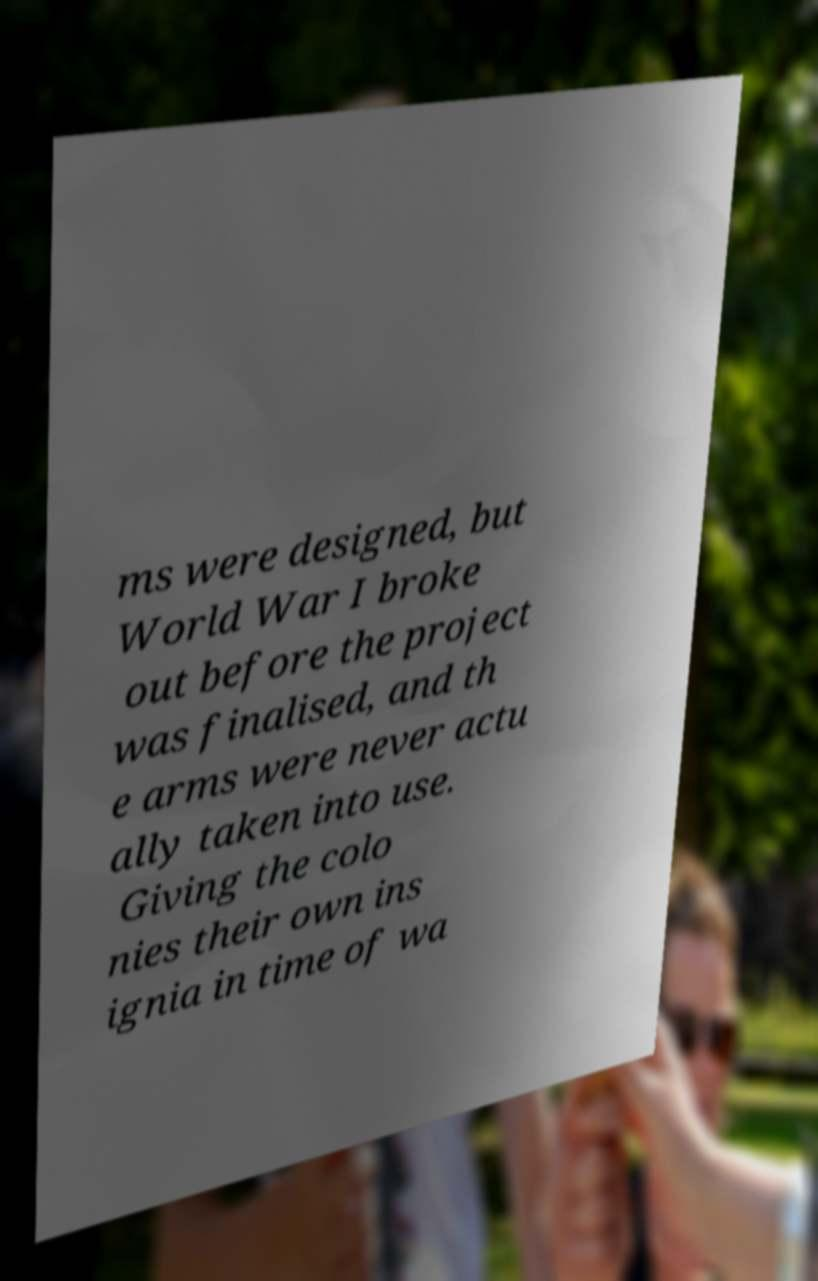What messages or text are displayed in this image? I need them in a readable, typed format. ms were designed, but World War I broke out before the project was finalised, and th e arms were never actu ally taken into use. Giving the colo nies their own ins ignia in time of wa 